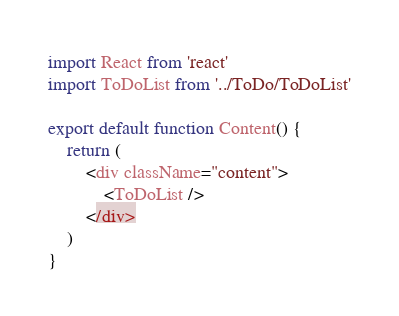Convert code to text. <code><loc_0><loc_0><loc_500><loc_500><_JavaScript_>import React from 'react'
import ToDoList from '../ToDo/ToDoList'

export default function Content() {
    return (
        <div className="content">
            <ToDoList />
        </div>
    )
}
</code> 